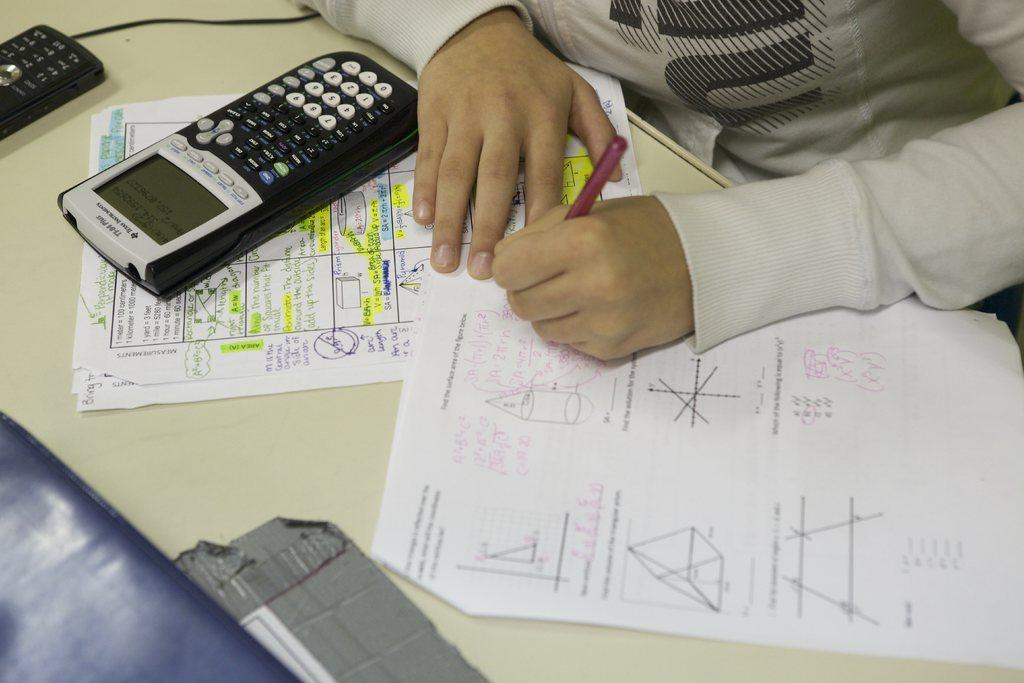Who is present in the image? There is a person in the image. What is the person holding in the image? The person is holding a pen. What can be seen on the table in the image? There are papers and a calculator on the table. Are there any other objects on the table in the image? Yes, there are other objects on the table. What type of substance is being used to pickle the rail in the image? There is no substance, pickle, or rail present in the image. 